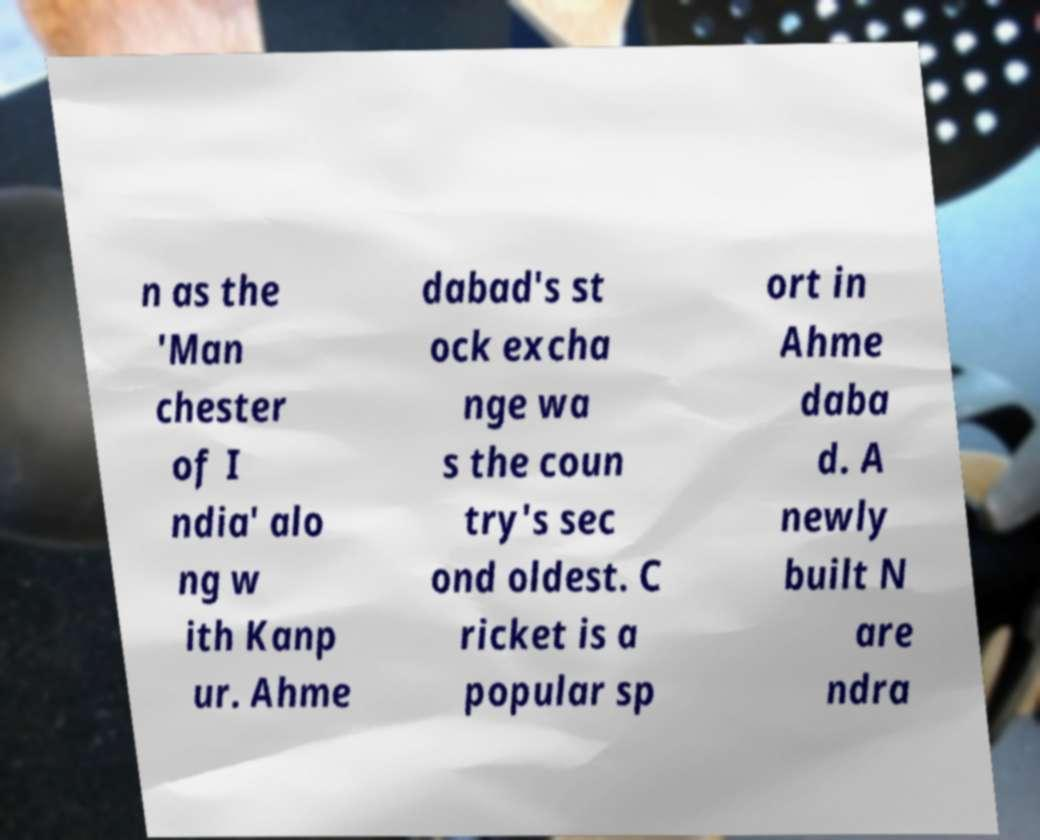For documentation purposes, I need the text within this image transcribed. Could you provide that? n as the 'Man chester of I ndia' alo ng w ith Kanp ur. Ahme dabad's st ock excha nge wa s the coun try's sec ond oldest. C ricket is a popular sp ort in Ahme daba d. A newly built N are ndra 